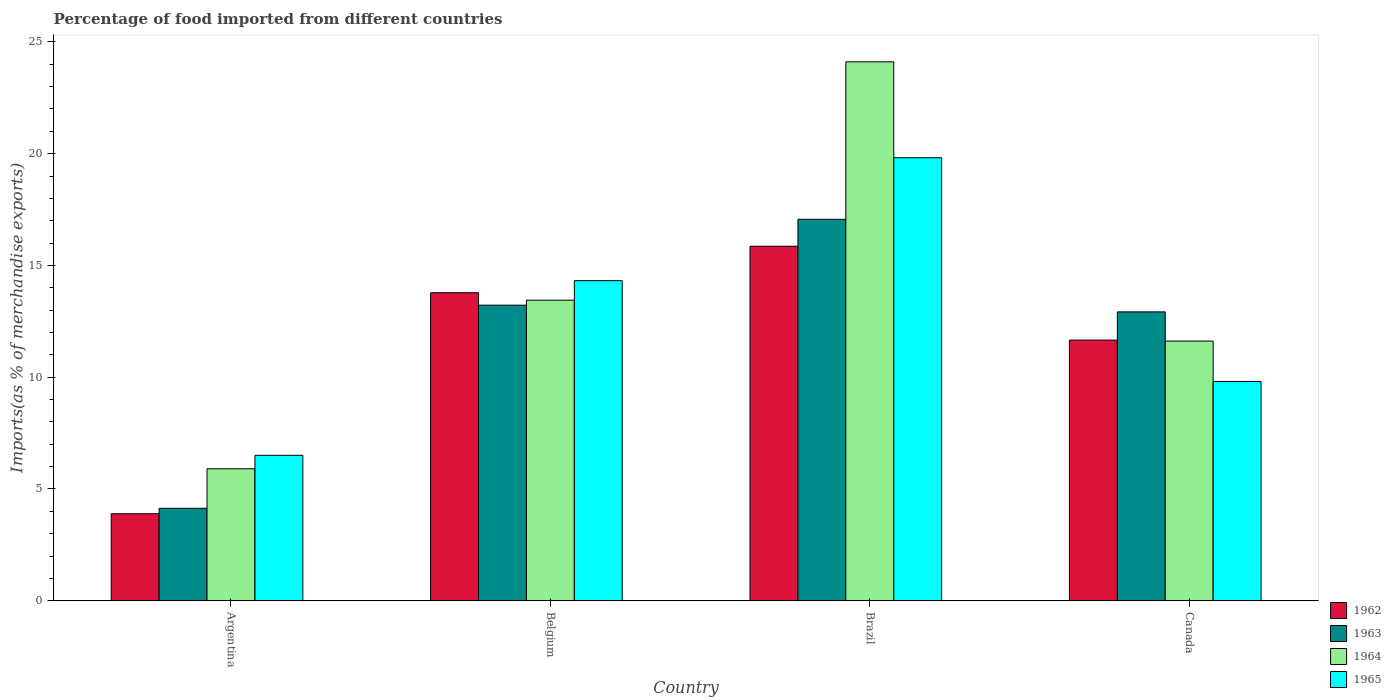How many groups of bars are there?
Ensure brevity in your answer.  4. Are the number of bars per tick equal to the number of legend labels?
Give a very brief answer. Yes. How many bars are there on the 3rd tick from the left?
Make the answer very short. 4. How many bars are there on the 2nd tick from the right?
Offer a very short reply. 4. In how many cases, is the number of bars for a given country not equal to the number of legend labels?
Ensure brevity in your answer.  0. What is the percentage of imports to different countries in 1965 in Belgium?
Give a very brief answer. 14.32. Across all countries, what is the maximum percentage of imports to different countries in 1962?
Offer a terse response. 15.86. Across all countries, what is the minimum percentage of imports to different countries in 1962?
Make the answer very short. 3.89. In which country was the percentage of imports to different countries in 1963 maximum?
Provide a succinct answer. Brazil. In which country was the percentage of imports to different countries in 1964 minimum?
Ensure brevity in your answer.  Argentina. What is the total percentage of imports to different countries in 1963 in the graph?
Offer a terse response. 47.35. What is the difference between the percentage of imports to different countries in 1965 in Argentina and that in Brazil?
Give a very brief answer. -13.31. What is the difference between the percentage of imports to different countries in 1965 in Belgium and the percentage of imports to different countries in 1963 in Canada?
Provide a short and direct response. 1.4. What is the average percentage of imports to different countries in 1965 per country?
Make the answer very short. 12.61. What is the difference between the percentage of imports to different countries of/in 1962 and percentage of imports to different countries of/in 1965 in Canada?
Make the answer very short. 1.85. In how many countries, is the percentage of imports to different countries in 1962 greater than 5 %?
Give a very brief answer. 3. What is the ratio of the percentage of imports to different countries in 1965 in Argentina to that in Brazil?
Your answer should be very brief. 0.33. Is the percentage of imports to different countries in 1962 in Belgium less than that in Brazil?
Provide a succinct answer. Yes. Is the difference between the percentage of imports to different countries in 1962 in Argentina and Brazil greater than the difference between the percentage of imports to different countries in 1965 in Argentina and Brazil?
Offer a terse response. Yes. What is the difference between the highest and the second highest percentage of imports to different countries in 1962?
Your response must be concise. -2.12. What is the difference between the highest and the lowest percentage of imports to different countries in 1963?
Ensure brevity in your answer.  12.93. Is it the case that in every country, the sum of the percentage of imports to different countries in 1965 and percentage of imports to different countries in 1963 is greater than the sum of percentage of imports to different countries in 1964 and percentage of imports to different countries in 1962?
Offer a terse response. No. What does the 1st bar from the right in Argentina represents?
Provide a short and direct response. 1965. Where does the legend appear in the graph?
Offer a terse response. Bottom right. How many legend labels are there?
Keep it short and to the point. 4. How are the legend labels stacked?
Your answer should be compact. Vertical. What is the title of the graph?
Make the answer very short. Percentage of food imported from different countries. Does "1982" appear as one of the legend labels in the graph?
Make the answer very short. No. What is the label or title of the X-axis?
Give a very brief answer. Country. What is the label or title of the Y-axis?
Give a very brief answer. Imports(as % of merchandise exports). What is the Imports(as % of merchandise exports) in 1962 in Argentina?
Make the answer very short. 3.89. What is the Imports(as % of merchandise exports) in 1963 in Argentina?
Keep it short and to the point. 4.14. What is the Imports(as % of merchandise exports) of 1964 in Argentina?
Make the answer very short. 5.91. What is the Imports(as % of merchandise exports) of 1965 in Argentina?
Offer a terse response. 6.51. What is the Imports(as % of merchandise exports) of 1962 in Belgium?
Your response must be concise. 13.78. What is the Imports(as % of merchandise exports) of 1963 in Belgium?
Provide a succinct answer. 13.22. What is the Imports(as % of merchandise exports) in 1964 in Belgium?
Your response must be concise. 13.45. What is the Imports(as % of merchandise exports) of 1965 in Belgium?
Give a very brief answer. 14.32. What is the Imports(as % of merchandise exports) of 1962 in Brazil?
Give a very brief answer. 15.86. What is the Imports(as % of merchandise exports) in 1963 in Brazil?
Make the answer very short. 17.06. What is the Imports(as % of merchandise exports) in 1964 in Brazil?
Your answer should be compact. 24.11. What is the Imports(as % of merchandise exports) of 1965 in Brazil?
Give a very brief answer. 19.82. What is the Imports(as % of merchandise exports) in 1962 in Canada?
Your response must be concise. 11.66. What is the Imports(as % of merchandise exports) of 1963 in Canada?
Offer a terse response. 12.92. What is the Imports(as % of merchandise exports) of 1964 in Canada?
Ensure brevity in your answer.  11.62. What is the Imports(as % of merchandise exports) in 1965 in Canada?
Ensure brevity in your answer.  9.81. Across all countries, what is the maximum Imports(as % of merchandise exports) in 1962?
Keep it short and to the point. 15.86. Across all countries, what is the maximum Imports(as % of merchandise exports) of 1963?
Ensure brevity in your answer.  17.06. Across all countries, what is the maximum Imports(as % of merchandise exports) of 1964?
Your answer should be compact. 24.11. Across all countries, what is the maximum Imports(as % of merchandise exports) of 1965?
Provide a short and direct response. 19.82. Across all countries, what is the minimum Imports(as % of merchandise exports) of 1962?
Keep it short and to the point. 3.89. Across all countries, what is the minimum Imports(as % of merchandise exports) in 1963?
Make the answer very short. 4.14. Across all countries, what is the minimum Imports(as % of merchandise exports) of 1964?
Provide a succinct answer. 5.91. Across all countries, what is the minimum Imports(as % of merchandise exports) in 1965?
Give a very brief answer. 6.51. What is the total Imports(as % of merchandise exports) in 1962 in the graph?
Ensure brevity in your answer.  45.19. What is the total Imports(as % of merchandise exports) in 1963 in the graph?
Offer a very short reply. 47.35. What is the total Imports(as % of merchandise exports) of 1964 in the graph?
Keep it short and to the point. 55.08. What is the total Imports(as % of merchandise exports) in 1965 in the graph?
Ensure brevity in your answer.  50.46. What is the difference between the Imports(as % of merchandise exports) in 1962 in Argentina and that in Belgium?
Your answer should be compact. -9.89. What is the difference between the Imports(as % of merchandise exports) of 1963 in Argentina and that in Belgium?
Make the answer very short. -9.09. What is the difference between the Imports(as % of merchandise exports) of 1964 in Argentina and that in Belgium?
Provide a succinct answer. -7.54. What is the difference between the Imports(as % of merchandise exports) in 1965 in Argentina and that in Belgium?
Make the answer very short. -7.81. What is the difference between the Imports(as % of merchandise exports) of 1962 in Argentina and that in Brazil?
Keep it short and to the point. -11.97. What is the difference between the Imports(as % of merchandise exports) of 1963 in Argentina and that in Brazil?
Make the answer very short. -12.93. What is the difference between the Imports(as % of merchandise exports) in 1964 in Argentina and that in Brazil?
Make the answer very short. -18.2. What is the difference between the Imports(as % of merchandise exports) of 1965 in Argentina and that in Brazil?
Ensure brevity in your answer.  -13.31. What is the difference between the Imports(as % of merchandise exports) of 1962 in Argentina and that in Canada?
Your response must be concise. -7.77. What is the difference between the Imports(as % of merchandise exports) of 1963 in Argentina and that in Canada?
Your answer should be very brief. -8.79. What is the difference between the Imports(as % of merchandise exports) of 1964 in Argentina and that in Canada?
Give a very brief answer. -5.71. What is the difference between the Imports(as % of merchandise exports) of 1965 in Argentina and that in Canada?
Make the answer very short. -3.3. What is the difference between the Imports(as % of merchandise exports) of 1962 in Belgium and that in Brazil?
Provide a succinct answer. -2.08. What is the difference between the Imports(as % of merchandise exports) of 1963 in Belgium and that in Brazil?
Your answer should be compact. -3.84. What is the difference between the Imports(as % of merchandise exports) of 1964 in Belgium and that in Brazil?
Your answer should be very brief. -10.66. What is the difference between the Imports(as % of merchandise exports) of 1965 in Belgium and that in Brazil?
Your answer should be compact. -5.5. What is the difference between the Imports(as % of merchandise exports) of 1962 in Belgium and that in Canada?
Your answer should be compact. 2.12. What is the difference between the Imports(as % of merchandise exports) of 1963 in Belgium and that in Canada?
Keep it short and to the point. 0.3. What is the difference between the Imports(as % of merchandise exports) of 1964 in Belgium and that in Canada?
Provide a short and direct response. 1.83. What is the difference between the Imports(as % of merchandise exports) of 1965 in Belgium and that in Canada?
Offer a very short reply. 4.51. What is the difference between the Imports(as % of merchandise exports) of 1962 in Brazil and that in Canada?
Ensure brevity in your answer.  4.2. What is the difference between the Imports(as % of merchandise exports) in 1963 in Brazil and that in Canada?
Make the answer very short. 4.14. What is the difference between the Imports(as % of merchandise exports) of 1964 in Brazil and that in Canada?
Your answer should be very brief. 12.49. What is the difference between the Imports(as % of merchandise exports) in 1965 in Brazil and that in Canada?
Your answer should be very brief. 10.01. What is the difference between the Imports(as % of merchandise exports) in 1962 in Argentina and the Imports(as % of merchandise exports) in 1963 in Belgium?
Your response must be concise. -9.33. What is the difference between the Imports(as % of merchandise exports) of 1962 in Argentina and the Imports(as % of merchandise exports) of 1964 in Belgium?
Keep it short and to the point. -9.55. What is the difference between the Imports(as % of merchandise exports) of 1962 in Argentina and the Imports(as % of merchandise exports) of 1965 in Belgium?
Make the answer very short. -10.43. What is the difference between the Imports(as % of merchandise exports) in 1963 in Argentina and the Imports(as % of merchandise exports) in 1964 in Belgium?
Your answer should be compact. -9.31. What is the difference between the Imports(as % of merchandise exports) in 1963 in Argentina and the Imports(as % of merchandise exports) in 1965 in Belgium?
Make the answer very short. -10.18. What is the difference between the Imports(as % of merchandise exports) in 1964 in Argentina and the Imports(as % of merchandise exports) in 1965 in Belgium?
Your response must be concise. -8.41. What is the difference between the Imports(as % of merchandise exports) in 1962 in Argentina and the Imports(as % of merchandise exports) in 1963 in Brazil?
Provide a succinct answer. -13.17. What is the difference between the Imports(as % of merchandise exports) of 1962 in Argentina and the Imports(as % of merchandise exports) of 1964 in Brazil?
Your answer should be very brief. -20.21. What is the difference between the Imports(as % of merchandise exports) of 1962 in Argentina and the Imports(as % of merchandise exports) of 1965 in Brazil?
Your answer should be compact. -15.92. What is the difference between the Imports(as % of merchandise exports) of 1963 in Argentina and the Imports(as % of merchandise exports) of 1964 in Brazil?
Provide a succinct answer. -19.97. What is the difference between the Imports(as % of merchandise exports) in 1963 in Argentina and the Imports(as % of merchandise exports) in 1965 in Brazil?
Make the answer very short. -15.68. What is the difference between the Imports(as % of merchandise exports) in 1964 in Argentina and the Imports(as % of merchandise exports) in 1965 in Brazil?
Offer a very short reply. -13.91. What is the difference between the Imports(as % of merchandise exports) of 1962 in Argentina and the Imports(as % of merchandise exports) of 1963 in Canada?
Provide a succinct answer. -9.03. What is the difference between the Imports(as % of merchandise exports) in 1962 in Argentina and the Imports(as % of merchandise exports) in 1964 in Canada?
Provide a succinct answer. -7.72. What is the difference between the Imports(as % of merchandise exports) of 1962 in Argentina and the Imports(as % of merchandise exports) of 1965 in Canada?
Your response must be concise. -5.92. What is the difference between the Imports(as % of merchandise exports) in 1963 in Argentina and the Imports(as % of merchandise exports) in 1964 in Canada?
Make the answer very short. -7.48. What is the difference between the Imports(as % of merchandise exports) in 1963 in Argentina and the Imports(as % of merchandise exports) in 1965 in Canada?
Provide a succinct answer. -5.67. What is the difference between the Imports(as % of merchandise exports) of 1964 in Argentina and the Imports(as % of merchandise exports) of 1965 in Canada?
Provide a short and direct response. -3.91. What is the difference between the Imports(as % of merchandise exports) of 1962 in Belgium and the Imports(as % of merchandise exports) of 1963 in Brazil?
Provide a short and direct response. -3.28. What is the difference between the Imports(as % of merchandise exports) in 1962 in Belgium and the Imports(as % of merchandise exports) in 1964 in Brazil?
Keep it short and to the point. -10.33. What is the difference between the Imports(as % of merchandise exports) of 1962 in Belgium and the Imports(as % of merchandise exports) of 1965 in Brazil?
Provide a succinct answer. -6.04. What is the difference between the Imports(as % of merchandise exports) in 1963 in Belgium and the Imports(as % of merchandise exports) in 1964 in Brazil?
Provide a short and direct response. -10.88. What is the difference between the Imports(as % of merchandise exports) in 1963 in Belgium and the Imports(as % of merchandise exports) in 1965 in Brazil?
Provide a short and direct response. -6.59. What is the difference between the Imports(as % of merchandise exports) in 1964 in Belgium and the Imports(as % of merchandise exports) in 1965 in Brazil?
Provide a short and direct response. -6.37. What is the difference between the Imports(as % of merchandise exports) in 1962 in Belgium and the Imports(as % of merchandise exports) in 1963 in Canada?
Keep it short and to the point. 0.86. What is the difference between the Imports(as % of merchandise exports) of 1962 in Belgium and the Imports(as % of merchandise exports) of 1964 in Canada?
Give a very brief answer. 2.16. What is the difference between the Imports(as % of merchandise exports) in 1962 in Belgium and the Imports(as % of merchandise exports) in 1965 in Canada?
Your response must be concise. 3.97. What is the difference between the Imports(as % of merchandise exports) in 1963 in Belgium and the Imports(as % of merchandise exports) in 1964 in Canada?
Your answer should be compact. 1.61. What is the difference between the Imports(as % of merchandise exports) of 1963 in Belgium and the Imports(as % of merchandise exports) of 1965 in Canada?
Ensure brevity in your answer.  3.41. What is the difference between the Imports(as % of merchandise exports) in 1964 in Belgium and the Imports(as % of merchandise exports) in 1965 in Canada?
Your response must be concise. 3.63. What is the difference between the Imports(as % of merchandise exports) in 1962 in Brazil and the Imports(as % of merchandise exports) in 1963 in Canada?
Your answer should be very brief. 2.94. What is the difference between the Imports(as % of merchandise exports) in 1962 in Brazil and the Imports(as % of merchandise exports) in 1964 in Canada?
Provide a short and direct response. 4.24. What is the difference between the Imports(as % of merchandise exports) in 1962 in Brazil and the Imports(as % of merchandise exports) in 1965 in Canada?
Make the answer very short. 6.05. What is the difference between the Imports(as % of merchandise exports) of 1963 in Brazil and the Imports(as % of merchandise exports) of 1964 in Canada?
Make the answer very short. 5.45. What is the difference between the Imports(as % of merchandise exports) in 1963 in Brazil and the Imports(as % of merchandise exports) in 1965 in Canada?
Ensure brevity in your answer.  7.25. What is the difference between the Imports(as % of merchandise exports) in 1964 in Brazil and the Imports(as % of merchandise exports) in 1965 in Canada?
Offer a very short reply. 14.3. What is the average Imports(as % of merchandise exports) of 1962 per country?
Provide a short and direct response. 11.3. What is the average Imports(as % of merchandise exports) of 1963 per country?
Your answer should be very brief. 11.84. What is the average Imports(as % of merchandise exports) in 1964 per country?
Ensure brevity in your answer.  13.77. What is the average Imports(as % of merchandise exports) of 1965 per country?
Make the answer very short. 12.61. What is the difference between the Imports(as % of merchandise exports) in 1962 and Imports(as % of merchandise exports) in 1963 in Argentina?
Ensure brevity in your answer.  -0.24. What is the difference between the Imports(as % of merchandise exports) of 1962 and Imports(as % of merchandise exports) of 1964 in Argentina?
Give a very brief answer. -2.01. What is the difference between the Imports(as % of merchandise exports) of 1962 and Imports(as % of merchandise exports) of 1965 in Argentina?
Provide a succinct answer. -2.61. What is the difference between the Imports(as % of merchandise exports) in 1963 and Imports(as % of merchandise exports) in 1964 in Argentina?
Offer a very short reply. -1.77. What is the difference between the Imports(as % of merchandise exports) of 1963 and Imports(as % of merchandise exports) of 1965 in Argentina?
Offer a very short reply. -2.37. What is the difference between the Imports(as % of merchandise exports) of 1964 and Imports(as % of merchandise exports) of 1965 in Argentina?
Your answer should be very brief. -0.6. What is the difference between the Imports(as % of merchandise exports) of 1962 and Imports(as % of merchandise exports) of 1963 in Belgium?
Offer a very short reply. 0.56. What is the difference between the Imports(as % of merchandise exports) of 1962 and Imports(as % of merchandise exports) of 1964 in Belgium?
Keep it short and to the point. 0.33. What is the difference between the Imports(as % of merchandise exports) in 1962 and Imports(as % of merchandise exports) in 1965 in Belgium?
Your answer should be compact. -0.54. What is the difference between the Imports(as % of merchandise exports) in 1963 and Imports(as % of merchandise exports) in 1964 in Belgium?
Offer a very short reply. -0.22. What is the difference between the Imports(as % of merchandise exports) of 1963 and Imports(as % of merchandise exports) of 1965 in Belgium?
Your answer should be very brief. -1.1. What is the difference between the Imports(as % of merchandise exports) in 1964 and Imports(as % of merchandise exports) in 1965 in Belgium?
Your response must be concise. -0.87. What is the difference between the Imports(as % of merchandise exports) of 1962 and Imports(as % of merchandise exports) of 1963 in Brazil?
Your answer should be compact. -1.2. What is the difference between the Imports(as % of merchandise exports) of 1962 and Imports(as % of merchandise exports) of 1964 in Brazil?
Keep it short and to the point. -8.25. What is the difference between the Imports(as % of merchandise exports) of 1962 and Imports(as % of merchandise exports) of 1965 in Brazil?
Provide a short and direct response. -3.96. What is the difference between the Imports(as % of merchandise exports) in 1963 and Imports(as % of merchandise exports) in 1964 in Brazil?
Your answer should be very brief. -7.04. What is the difference between the Imports(as % of merchandise exports) in 1963 and Imports(as % of merchandise exports) in 1965 in Brazil?
Offer a terse response. -2.75. What is the difference between the Imports(as % of merchandise exports) of 1964 and Imports(as % of merchandise exports) of 1965 in Brazil?
Provide a short and direct response. 4.29. What is the difference between the Imports(as % of merchandise exports) in 1962 and Imports(as % of merchandise exports) in 1963 in Canada?
Provide a short and direct response. -1.26. What is the difference between the Imports(as % of merchandise exports) in 1962 and Imports(as % of merchandise exports) in 1964 in Canada?
Your response must be concise. 0.05. What is the difference between the Imports(as % of merchandise exports) in 1962 and Imports(as % of merchandise exports) in 1965 in Canada?
Provide a short and direct response. 1.85. What is the difference between the Imports(as % of merchandise exports) of 1963 and Imports(as % of merchandise exports) of 1964 in Canada?
Provide a short and direct response. 1.31. What is the difference between the Imports(as % of merchandise exports) in 1963 and Imports(as % of merchandise exports) in 1965 in Canada?
Your response must be concise. 3.11. What is the difference between the Imports(as % of merchandise exports) of 1964 and Imports(as % of merchandise exports) of 1965 in Canada?
Provide a succinct answer. 1.8. What is the ratio of the Imports(as % of merchandise exports) in 1962 in Argentina to that in Belgium?
Provide a short and direct response. 0.28. What is the ratio of the Imports(as % of merchandise exports) of 1963 in Argentina to that in Belgium?
Your answer should be compact. 0.31. What is the ratio of the Imports(as % of merchandise exports) in 1964 in Argentina to that in Belgium?
Offer a very short reply. 0.44. What is the ratio of the Imports(as % of merchandise exports) of 1965 in Argentina to that in Belgium?
Provide a succinct answer. 0.45. What is the ratio of the Imports(as % of merchandise exports) in 1962 in Argentina to that in Brazil?
Ensure brevity in your answer.  0.25. What is the ratio of the Imports(as % of merchandise exports) of 1963 in Argentina to that in Brazil?
Your response must be concise. 0.24. What is the ratio of the Imports(as % of merchandise exports) of 1964 in Argentina to that in Brazil?
Ensure brevity in your answer.  0.24. What is the ratio of the Imports(as % of merchandise exports) of 1965 in Argentina to that in Brazil?
Ensure brevity in your answer.  0.33. What is the ratio of the Imports(as % of merchandise exports) in 1962 in Argentina to that in Canada?
Ensure brevity in your answer.  0.33. What is the ratio of the Imports(as % of merchandise exports) of 1963 in Argentina to that in Canada?
Give a very brief answer. 0.32. What is the ratio of the Imports(as % of merchandise exports) of 1964 in Argentina to that in Canada?
Your answer should be compact. 0.51. What is the ratio of the Imports(as % of merchandise exports) of 1965 in Argentina to that in Canada?
Your answer should be very brief. 0.66. What is the ratio of the Imports(as % of merchandise exports) in 1962 in Belgium to that in Brazil?
Ensure brevity in your answer.  0.87. What is the ratio of the Imports(as % of merchandise exports) in 1963 in Belgium to that in Brazil?
Offer a terse response. 0.77. What is the ratio of the Imports(as % of merchandise exports) of 1964 in Belgium to that in Brazil?
Keep it short and to the point. 0.56. What is the ratio of the Imports(as % of merchandise exports) of 1965 in Belgium to that in Brazil?
Provide a succinct answer. 0.72. What is the ratio of the Imports(as % of merchandise exports) in 1962 in Belgium to that in Canada?
Your response must be concise. 1.18. What is the ratio of the Imports(as % of merchandise exports) of 1963 in Belgium to that in Canada?
Your response must be concise. 1.02. What is the ratio of the Imports(as % of merchandise exports) of 1964 in Belgium to that in Canada?
Provide a succinct answer. 1.16. What is the ratio of the Imports(as % of merchandise exports) of 1965 in Belgium to that in Canada?
Your answer should be very brief. 1.46. What is the ratio of the Imports(as % of merchandise exports) of 1962 in Brazil to that in Canada?
Give a very brief answer. 1.36. What is the ratio of the Imports(as % of merchandise exports) in 1963 in Brazil to that in Canada?
Keep it short and to the point. 1.32. What is the ratio of the Imports(as % of merchandise exports) of 1964 in Brazil to that in Canada?
Provide a short and direct response. 2.08. What is the ratio of the Imports(as % of merchandise exports) of 1965 in Brazil to that in Canada?
Ensure brevity in your answer.  2.02. What is the difference between the highest and the second highest Imports(as % of merchandise exports) of 1962?
Your answer should be very brief. 2.08. What is the difference between the highest and the second highest Imports(as % of merchandise exports) of 1963?
Make the answer very short. 3.84. What is the difference between the highest and the second highest Imports(as % of merchandise exports) of 1964?
Your answer should be very brief. 10.66. What is the difference between the highest and the second highest Imports(as % of merchandise exports) of 1965?
Provide a short and direct response. 5.5. What is the difference between the highest and the lowest Imports(as % of merchandise exports) in 1962?
Offer a very short reply. 11.97. What is the difference between the highest and the lowest Imports(as % of merchandise exports) in 1963?
Provide a succinct answer. 12.93. What is the difference between the highest and the lowest Imports(as % of merchandise exports) in 1964?
Your response must be concise. 18.2. What is the difference between the highest and the lowest Imports(as % of merchandise exports) of 1965?
Your answer should be compact. 13.31. 